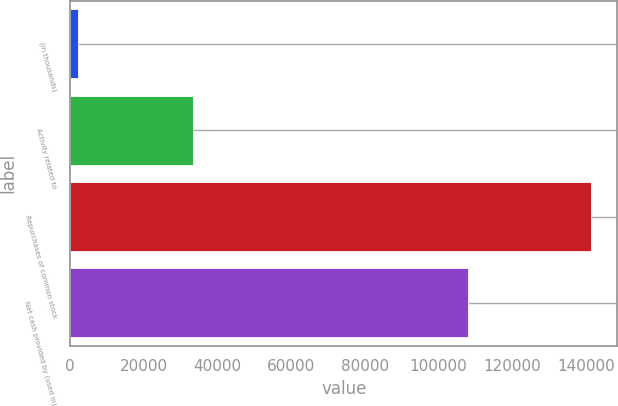Convert chart to OTSL. <chart><loc_0><loc_0><loc_500><loc_500><bar_chart><fcel>(in thousands)<fcel>Activity related to<fcel>Repurchases of common stock<fcel>Net cash provided by (used in)<nl><fcel>2012<fcel>33439<fcel>141468<fcel>108029<nl></chart> 